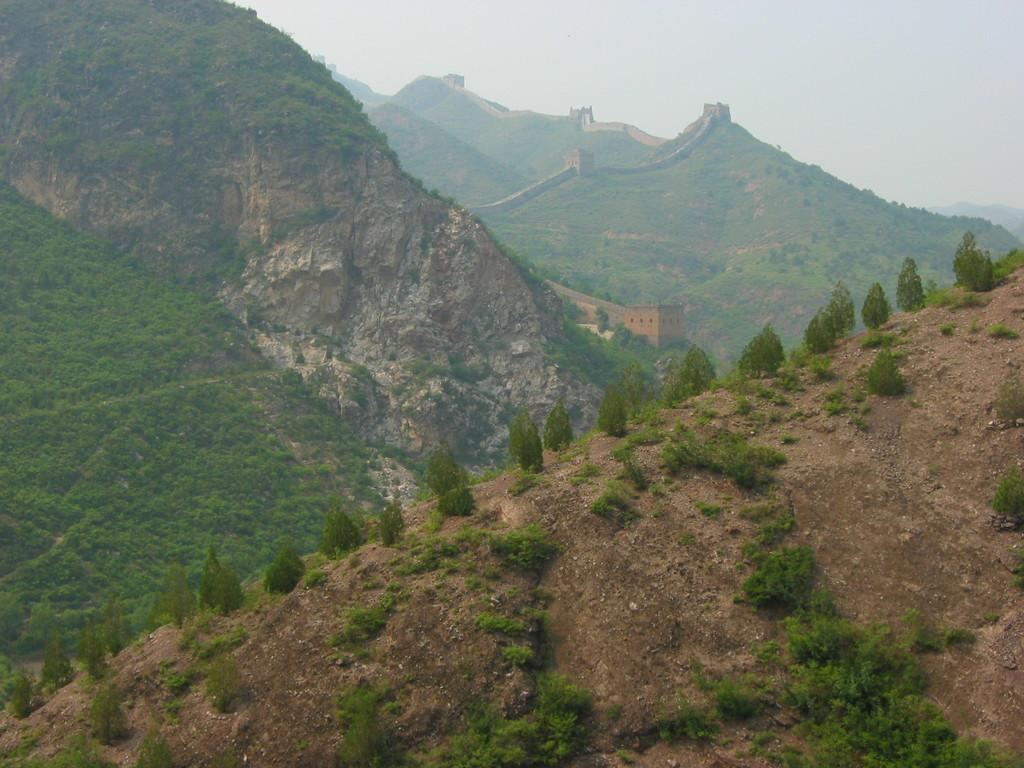What type of natural landscape can be seen in the image? There are mountains in the image. What type of vegetation is present in the image? There is grass in the image. What man-made structure is visible in the image? The Great Wall of China is visible in the image. What part of the sky is visible in the image? The sky is visible in the top right side of the image. What type of channel can be seen in the image? There is no channel present in the image. What type of bone is visible in the image? There is no bone visible in the image. 